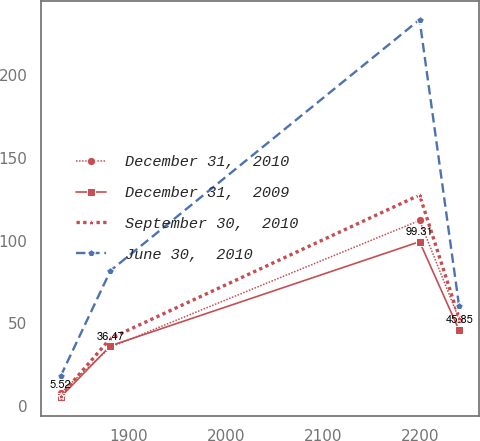Convert chart to OTSL. <chart><loc_0><loc_0><loc_500><loc_500><line_chart><ecel><fcel>December 31,  2010<fcel>December 31,  2009<fcel>September 30,  2010<fcel>June 30,  2010<nl><fcel>1829.34<fcel>8.22<fcel>5.52<fcel>6.32<fcel>18.19<nl><fcel>1880.76<fcel>35.6<fcel>36.47<fcel>40.98<fcel>81.85<nl><fcel>2199.9<fcel>112.15<fcel>99.31<fcel>127.51<fcel>233.39<nl><fcel>2240.75<fcel>52.46<fcel>45.85<fcel>53.1<fcel>60.33<nl></chart> 